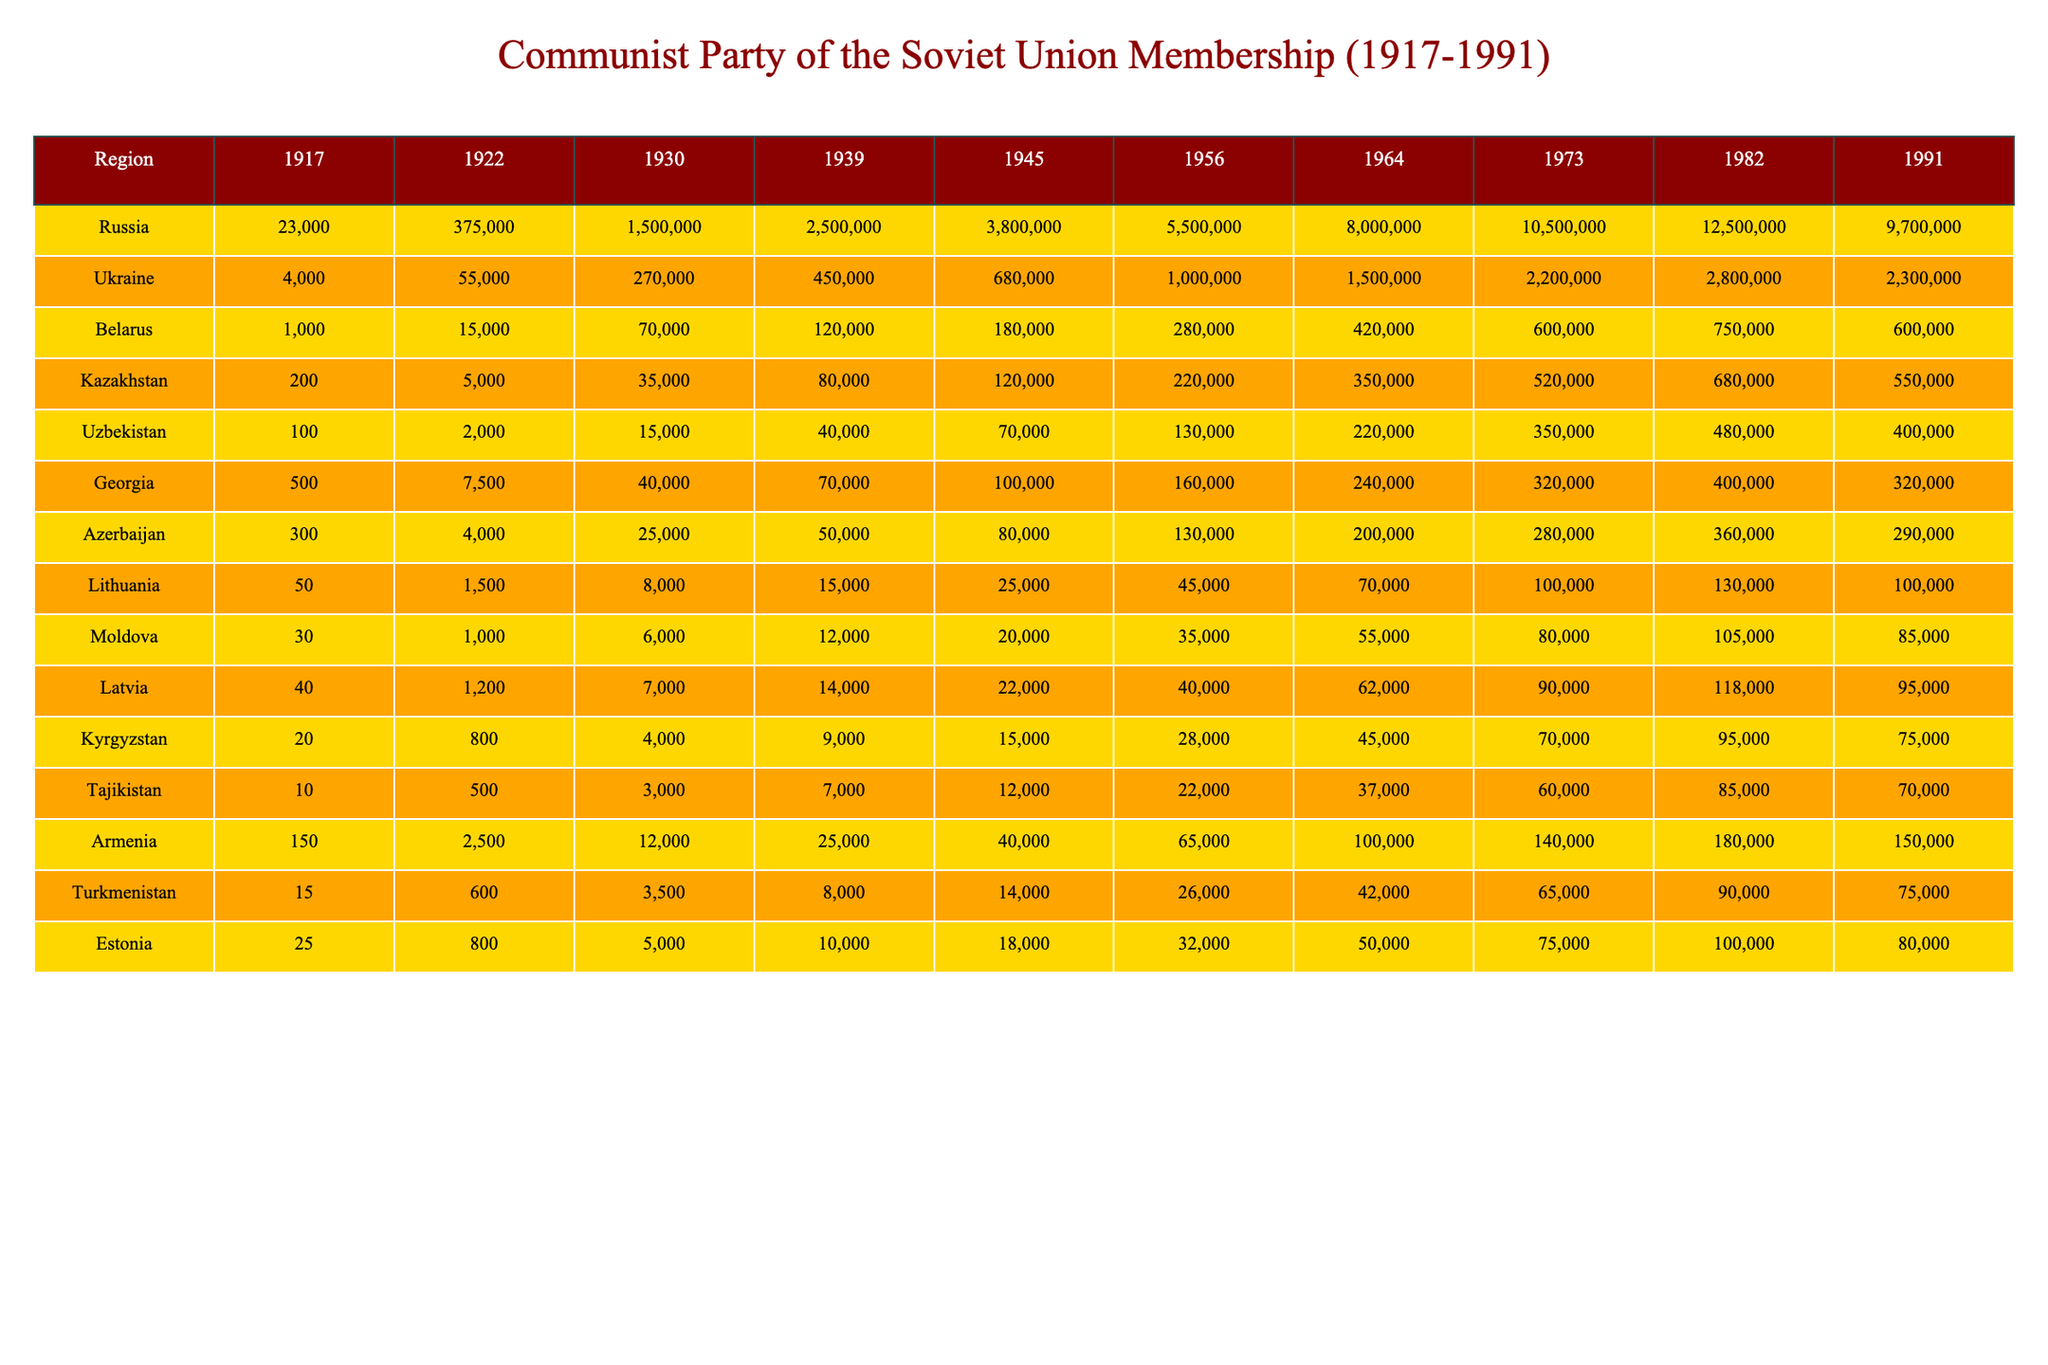What was the membership number in Russia in 1964? The table shows that in 1964, the membership number for Russia is listed directly under that year. Referring to the table, the value is 8,000,000.
Answer: 8,000,000 How many members did the Communist Party have in Ukraine in 1930? The table indicates that the membership number in Ukraine for the year 1930 is directly stated. Looking at the data for Ukraine in that year, the number is 270,000.
Answer: 270,000 Which region had the highest membership in 1982? To find this, compare the membership numbers from each region in 1982. The highest number is in Russia with 12,500,000.
Answer: Russia What was the total membership of the Communist Party across all regions in 1956? To calculate this total, sum the membership numbers for all listed regions in 1956: 5,500,000 (Russia) + 1,000,000 (Ukraine) + 280,000 (Belarus) + 220,000 (Kazakhstan) + 130,000 (Uzbekistan) + 160,000 (Georgia) + 130,000 (Azerbaijan) + 45,000 (Lithuania) + 35,000 (Moldova) + 40,000 (Latvia) + 28,000 (Kyrgyzstan) + 22,000 (Tajikistan) + 65,000 (Armenia) + 26,000 (Turkmenistan) + 32,000 (Estonia) = 8,355,000.
Answer: 8,355,000 Was there a decline in membership numbers in Kazakhstan from 1982 to 1991? To answer this, check the values for Kazakhstan in both years: 680,000 in 1982 and 550,000 in 1991. Since 680,000 > 550,000, there was a decline.
Answer: Yes What was the average membership in Latvia from 1956 to 1991? To determine this, add the membership numbers for Latvia in each year (40,000 in 1956; 62,000 in 1964; 90,000 in 1973; 118,000 in 1982; and 95,000 in 1991), which gives a total of 405,000. There are 5 data points, so the average is 405,000 / 5 = 81,000.
Answer: 81,000 Which region experienced the most significant growth from 1917 to 1991? Evaluate the membership change in each region by comparing the values from 1917 and 1991. For instance, Russia grew from 23,000 to 9,700,000, while other regions show less growth. Comparing these changes, Russia experienced the largest increase in membership.
Answer: Russia What was the total membership across all regions in 1945? To find this total, add the membership numbers for all regions in 1945: 3,800,000 (Russia) + 680,000 (Ukraine) + 180,000 (Belarus) + 120,000 (Kazakhstan) + 70,000 (Uzbekistan) + 100,000 (Georgia) + 80,000 (Azerbaijan) + 25,000 (Lithuania) + 20,000 (Moldova) + 22,000 (Latvia) + 15,000 (Kyrgyzstan) + 12,000 (Tajikistan) + 40,000 (Armenia) + 14,000 (Turkmenistan) + 18,000 (Estonia) = 5,097,000.
Answer: 5,097,000 How much higher was the membership in Ukraine in 1982 compared to 1956? To find the difference, look at the membership numbers for Ukraine in both years: in 1982, it was 2,800,000 and in 1956, it was 1,000,000. Thus, the difference is 2,800,000 - 1,000,000 = 1,800,000.
Answer: 1,800,000 Did Azerbaijan have a higher membership in 1973 or in 1991? Check the membership figures for Azerbaijan in both years: in 1973 it was 280,000, while in 1991 it dropped to 290,000. Therefore, Azerbaijan had a higher membership in 1991.
Answer: Yes 